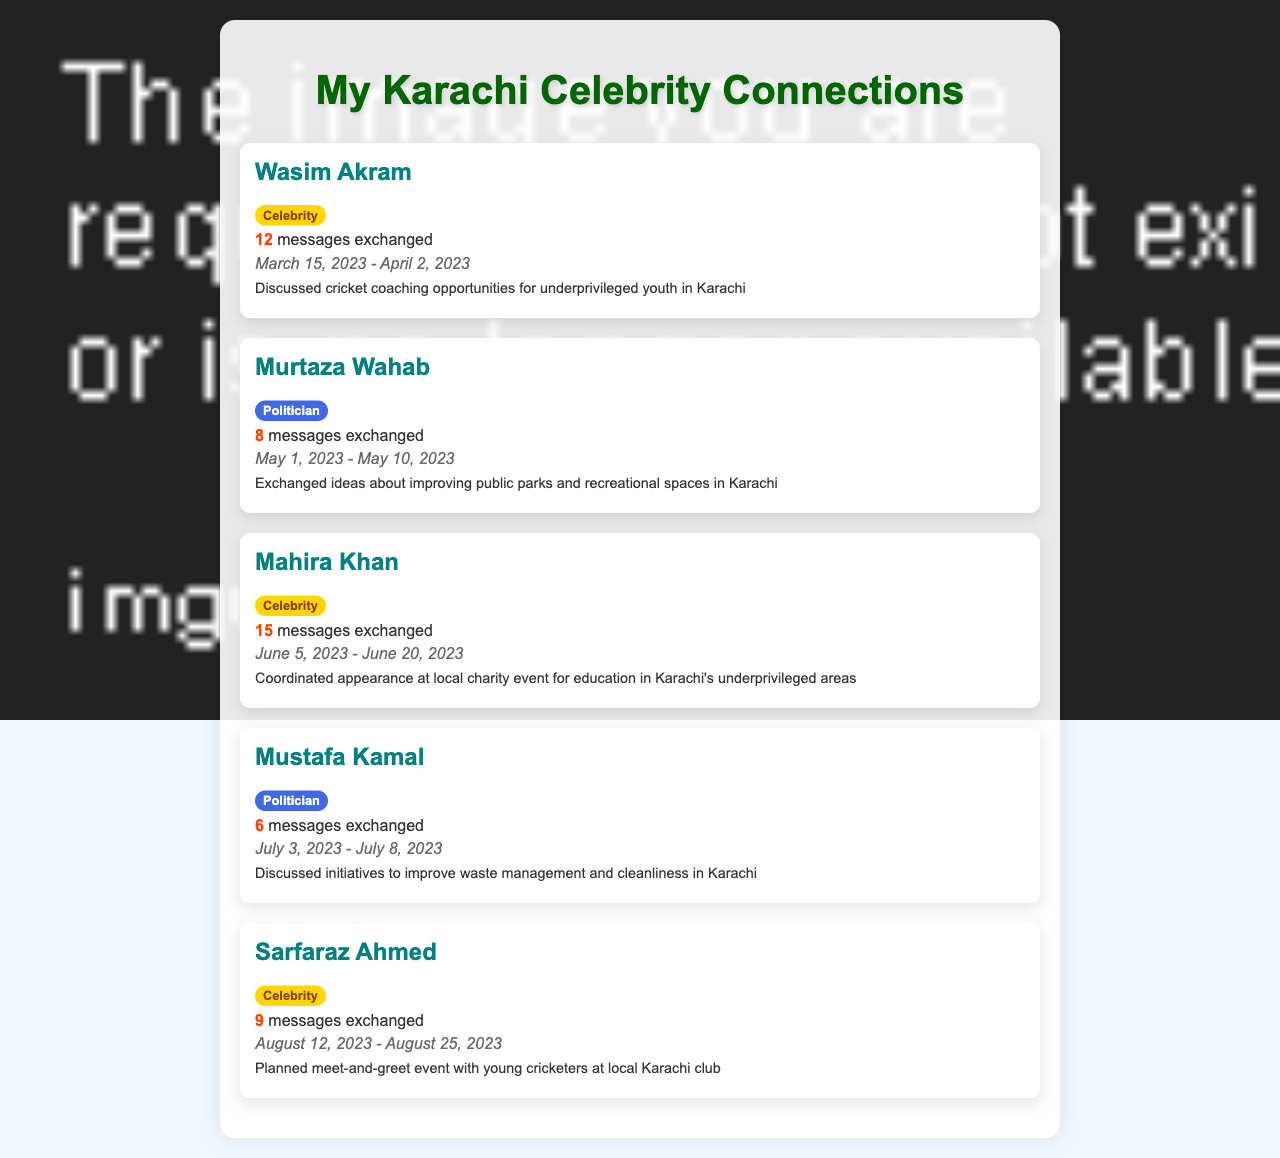What is the message count exchanged with Wasim Akram? The message count for Wasim Akram is stated in the document as 12 messages exchanged.
Answer: 12 What was the date range of messages exchanged with Mahira Khan? The date range is specified in the document from June 5, 2023 to June 20, 2023 for Mahira Khan.
Answer: June 5, 2023 - June 20, 2023 Who discussed waste management initiatives? The document indicates that Mustafa Kamal discussed initiatives to improve waste management and cleanliness in Karachi.
Answer: Mustafa Kamal How many messages were exchanged with Murtaza Wahab? The document mentions that 8 messages were exchanged with Murtaza Wahab.
Answer: 8 What was the main topic of discussion with Sarfaraz Ahmed? The summary notes that the main topic was a planned meet-and-greet event with young cricketers.
Answer: Meet-and-greet event with young cricketers Which celebrity had the highest message count? According to the document, Mahira Khan had the highest message count with 15 messages.
Answer: Mahira Khan What is the sum of the messages exchanged with all celebrities? The total messages exchanged can be calculated as 12 (Wasim Akram) + 15 (Mahira Khan) + 9 (Sarfaraz Ahmed) = 36 messages.
Answer: 36 Who is mentioned as a politician in the document? The document lists Murtaza Wahab and Mustafa Kamal as politicians.
Answer: Murtaza Wahab, Mustafa Kamal When did the conversation with Mustafa Kamal take place? The document specifies that the messages with Mustafa Kamal were exchanged from July 3, 2023 to July 8, 2023.
Answer: July 3, 2023 - July 8, 2023 